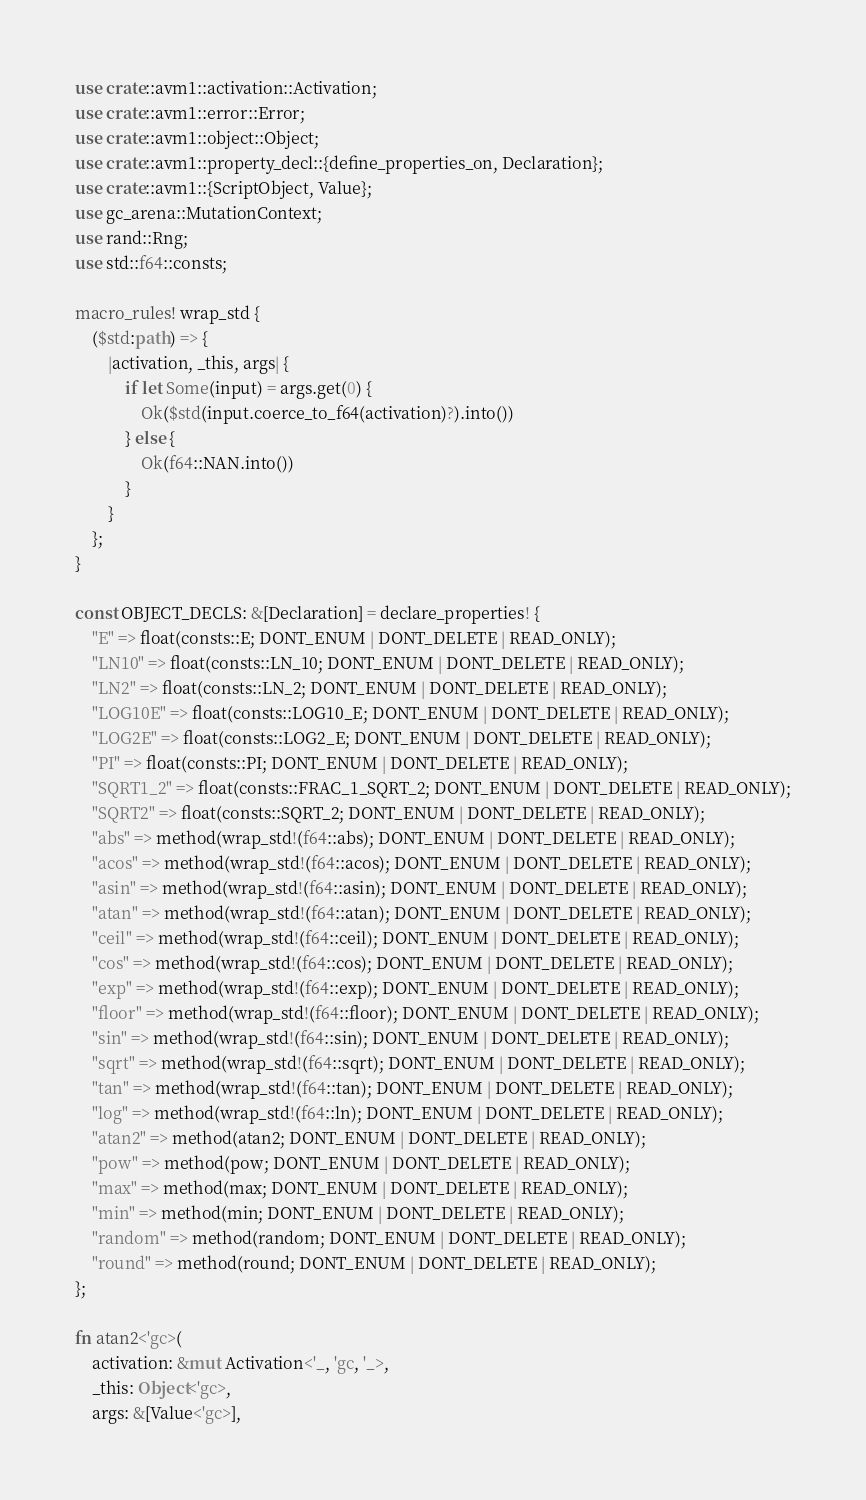<code> <loc_0><loc_0><loc_500><loc_500><_Rust_>use crate::avm1::activation::Activation;
use crate::avm1::error::Error;
use crate::avm1::object::Object;
use crate::avm1::property_decl::{define_properties_on, Declaration};
use crate::avm1::{ScriptObject, Value};
use gc_arena::MutationContext;
use rand::Rng;
use std::f64::consts;

macro_rules! wrap_std {
    ($std:path) => {
        |activation, _this, args| {
            if let Some(input) = args.get(0) {
                Ok($std(input.coerce_to_f64(activation)?).into())
            } else {
                Ok(f64::NAN.into())
            }
        }
    };
}

const OBJECT_DECLS: &[Declaration] = declare_properties! {
    "E" => float(consts::E; DONT_ENUM | DONT_DELETE | READ_ONLY);
    "LN10" => float(consts::LN_10; DONT_ENUM | DONT_DELETE | READ_ONLY);
    "LN2" => float(consts::LN_2; DONT_ENUM | DONT_DELETE | READ_ONLY);
    "LOG10E" => float(consts::LOG10_E; DONT_ENUM | DONT_DELETE | READ_ONLY);
    "LOG2E" => float(consts::LOG2_E; DONT_ENUM | DONT_DELETE | READ_ONLY);
    "PI" => float(consts::PI; DONT_ENUM | DONT_DELETE | READ_ONLY);
    "SQRT1_2" => float(consts::FRAC_1_SQRT_2; DONT_ENUM | DONT_DELETE | READ_ONLY);
    "SQRT2" => float(consts::SQRT_2; DONT_ENUM | DONT_DELETE | READ_ONLY);
    "abs" => method(wrap_std!(f64::abs); DONT_ENUM | DONT_DELETE | READ_ONLY);
    "acos" => method(wrap_std!(f64::acos); DONT_ENUM | DONT_DELETE | READ_ONLY);
    "asin" => method(wrap_std!(f64::asin); DONT_ENUM | DONT_DELETE | READ_ONLY);
    "atan" => method(wrap_std!(f64::atan); DONT_ENUM | DONT_DELETE | READ_ONLY);
    "ceil" => method(wrap_std!(f64::ceil); DONT_ENUM | DONT_DELETE | READ_ONLY);
    "cos" => method(wrap_std!(f64::cos); DONT_ENUM | DONT_DELETE | READ_ONLY);
    "exp" => method(wrap_std!(f64::exp); DONT_ENUM | DONT_DELETE | READ_ONLY);
    "floor" => method(wrap_std!(f64::floor); DONT_ENUM | DONT_DELETE | READ_ONLY);
    "sin" => method(wrap_std!(f64::sin); DONT_ENUM | DONT_DELETE | READ_ONLY);
    "sqrt" => method(wrap_std!(f64::sqrt); DONT_ENUM | DONT_DELETE | READ_ONLY);
    "tan" => method(wrap_std!(f64::tan); DONT_ENUM | DONT_DELETE | READ_ONLY);
    "log" => method(wrap_std!(f64::ln); DONT_ENUM | DONT_DELETE | READ_ONLY);
    "atan2" => method(atan2; DONT_ENUM | DONT_DELETE | READ_ONLY);
    "pow" => method(pow; DONT_ENUM | DONT_DELETE | READ_ONLY);
    "max" => method(max; DONT_ENUM | DONT_DELETE | READ_ONLY);
    "min" => method(min; DONT_ENUM | DONT_DELETE | READ_ONLY);
    "random" => method(random; DONT_ENUM | DONT_DELETE | READ_ONLY);
    "round" => method(round; DONT_ENUM | DONT_DELETE | READ_ONLY);
};

fn atan2<'gc>(
    activation: &mut Activation<'_, 'gc, '_>,
    _this: Object<'gc>,
    args: &[Value<'gc>],</code> 